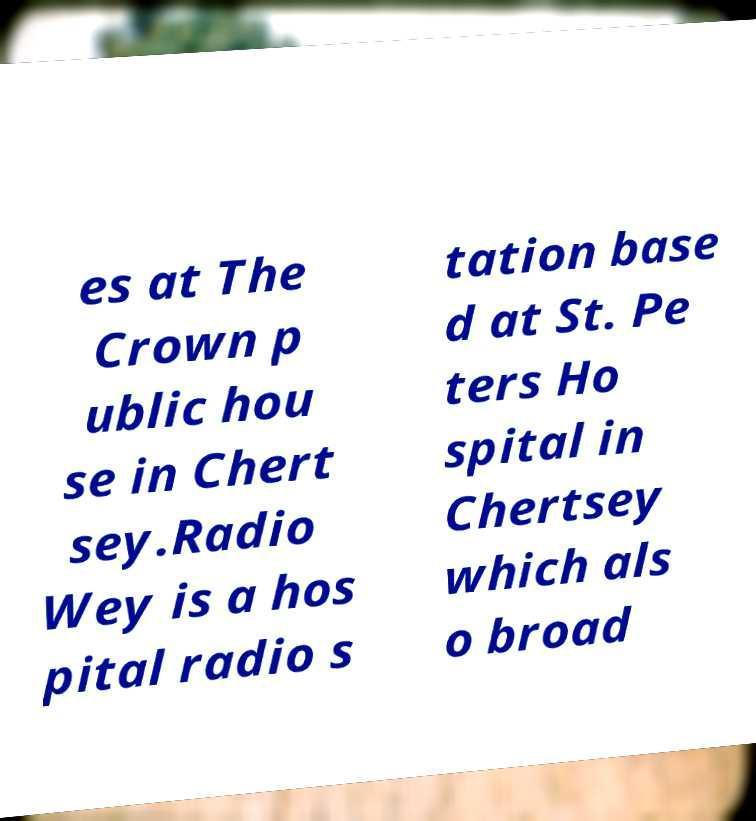I need the written content from this picture converted into text. Can you do that? es at The Crown p ublic hou se in Chert sey.Radio Wey is a hos pital radio s tation base d at St. Pe ters Ho spital in Chertsey which als o broad 